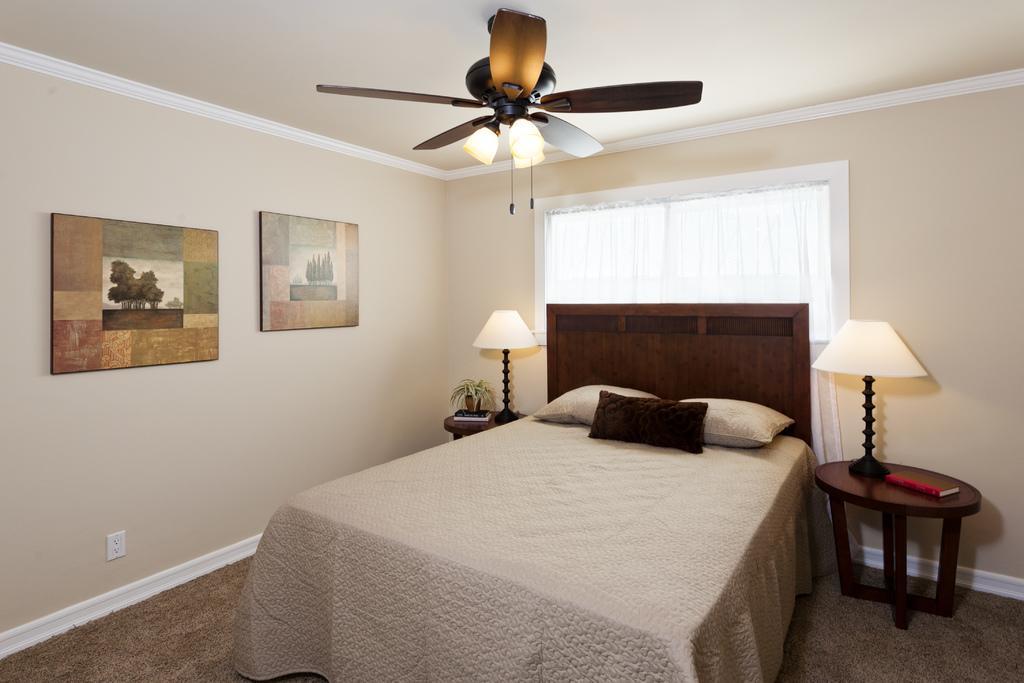In one or two sentences, can you explain what this image depicts? This image might be taken in a bedroom. In this image we can see bed, bed sheet, pillows, lights, book, table, photo frames, window, fan and wall. 